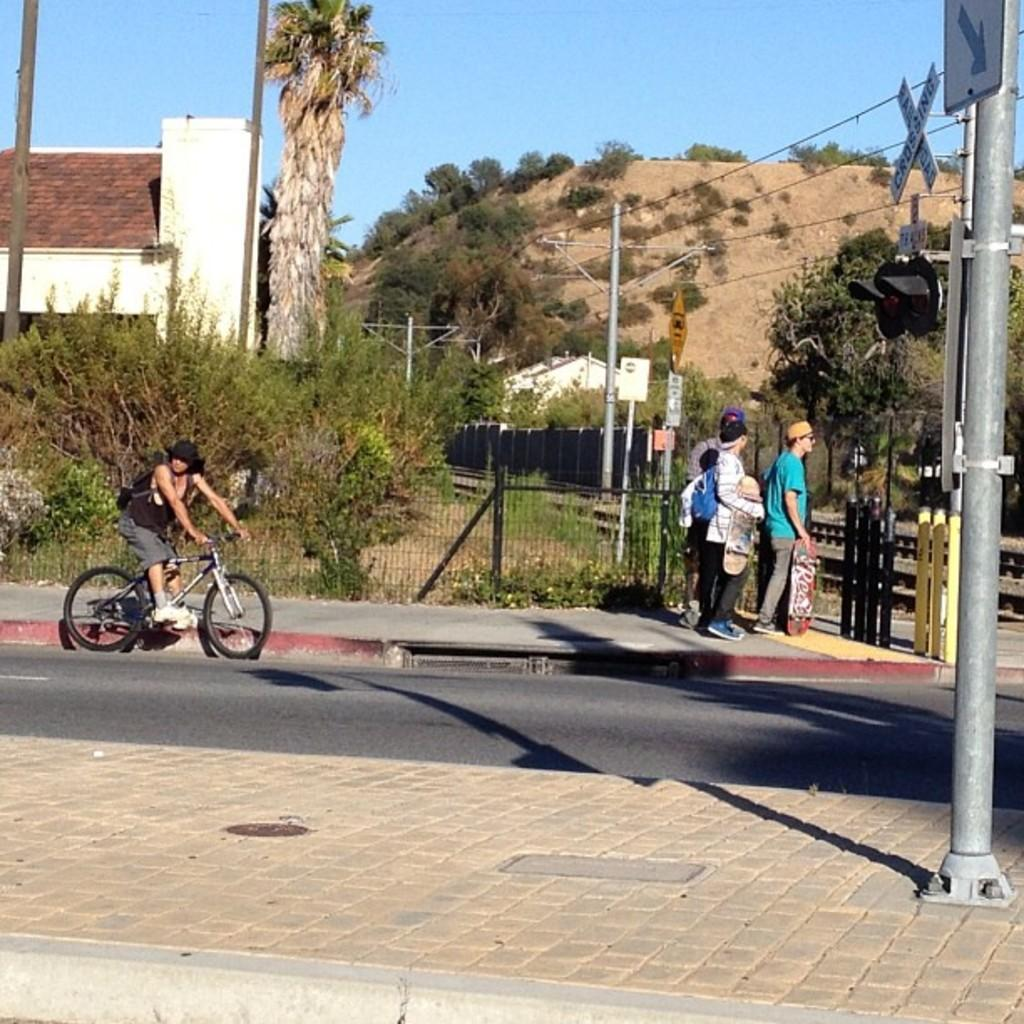What is the person in the image doing? The person is sitting on a bicycle. What are the people near the person holding? They are holding skateboards. What can be seen in the background of the image? There are plants, a fence, a tree, and a house in the background. What is attached to the pole in the image? Sign boards and a signal light are present on the pole. Where is the table located in the image? There is no table present in the image. Can you see a cellar in the image? There is no cellar visible in the image. 